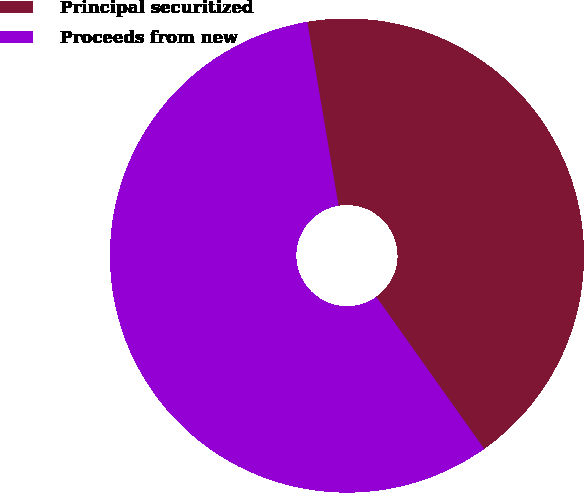Convert chart to OTSL. <chart><loc_0><loc_0><loc_500><loc_500><pie_chart><fcel>Principal securitized<fcel>Proceeds from new<nl><fcel>42.86%<fcel>57.14%<nl></chart> 